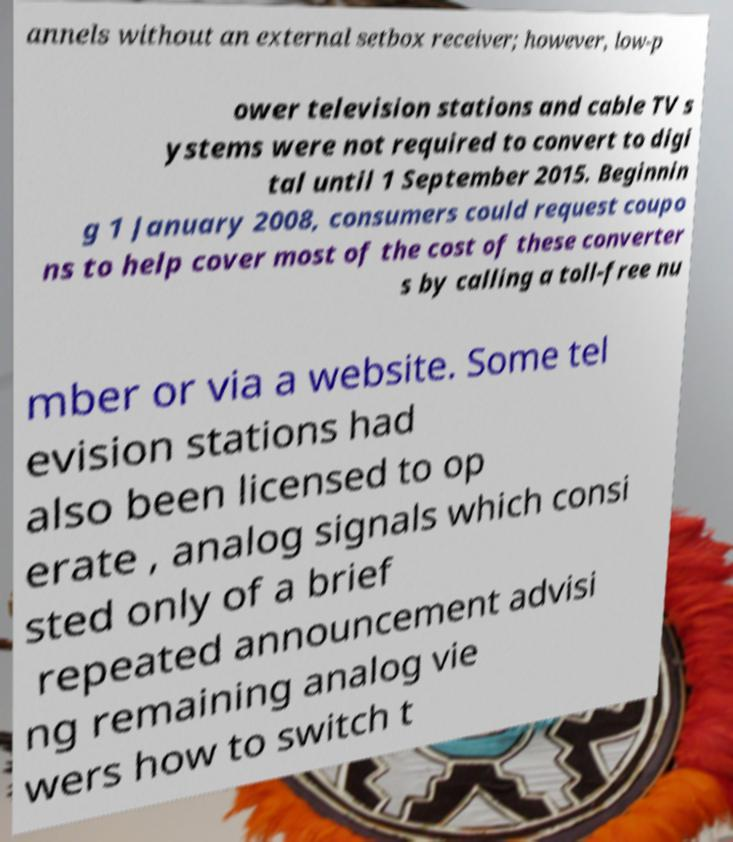I need the written content from this picture converted into text. Can you do that? annels without an external setbox receiver; however, low-p ower television stations and cable TV s ystems were not required to convert to digi tal until 1 September 2015. Beginnin g 1 January 2008, consumers could request coupo ns to help cover most of the cost of these converter s by calling a toll-free nu mber or via a website. Some tel evision stations had also been licensed to op erate , analog signals which consi sted only of a brief repeated announcement advisi ng remaining analog vie wers how to switch t 